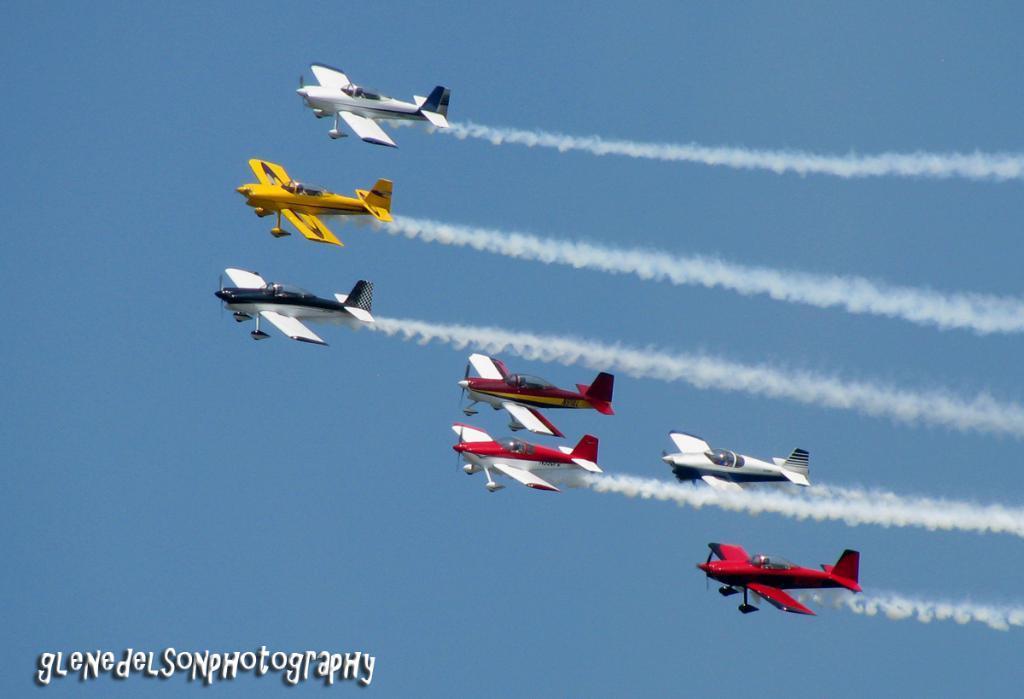In one or two sentences, can you explain what this image depicts? In this image we can see some airplanes are flying and in the background, we can see the sky, at the bottom of the image we can see the water mark. 